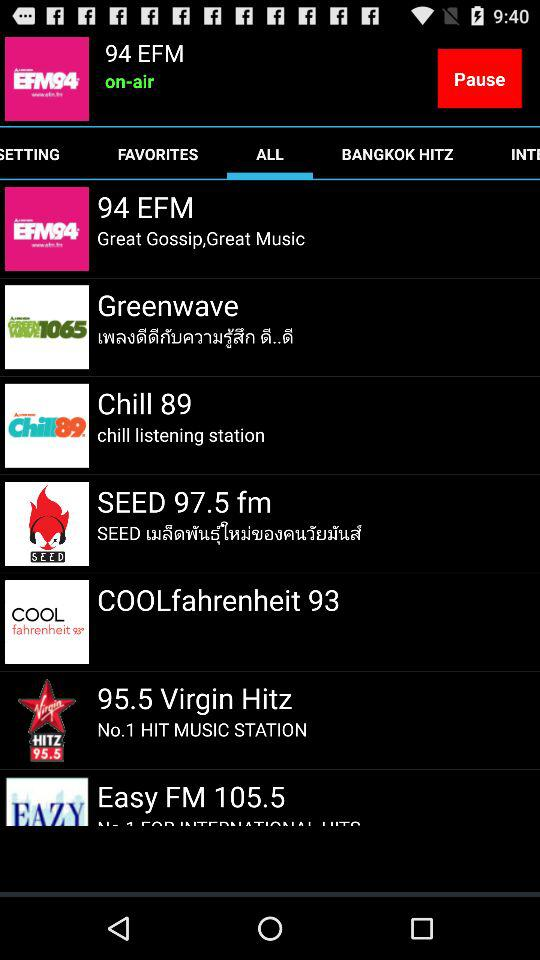Which channel is playing now? The channel "94 EFM" is playing now. 